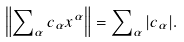<formula> <loc_0><loc_0><loc_500><loc_500>\left \| \sum \nolimits _ { \alpha } c _ { \alpha } x ^ { \alpha } \right \| = \sum \nolimits _ { \alpha } | c _ { \alpha } | .</formula> 